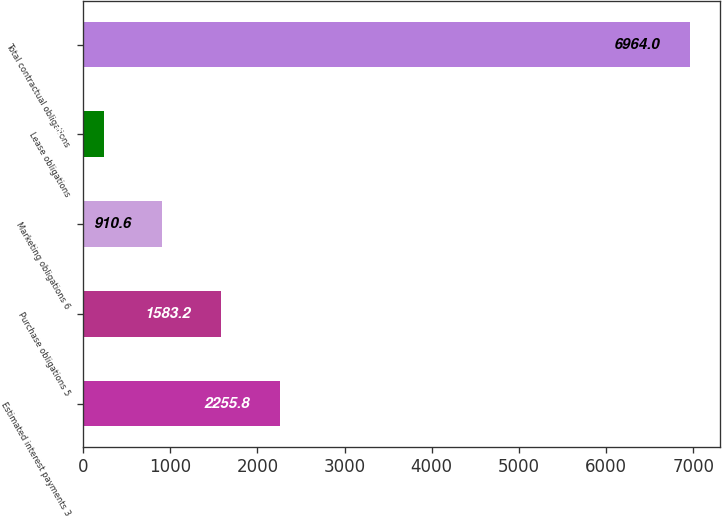<chart> <loc_0><loc_0><loc_500><loc_500><bar_chart><fcel>Estimated interest payments 3<fcel>Purchase obligations 5<fcel>Marketing obligations 6<fcel>Lease obligations<fcel>Total contractual obligations<nl><fcel>2255.8<fcel>1583.2<fcel>910.6<fcel>238<fcel>6964<nl></chart> 